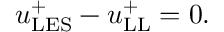Convert formula to latex. <formula><loc_0><loc_0><loc_500><loc_500>u _ { L E S } ^ { + } - u _ { L L } ^ { + } = 0 .</formula> 